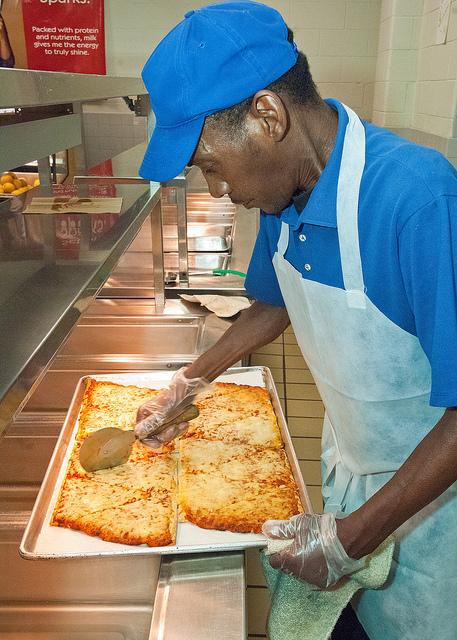What kind of meat is in the pan?
Answer briefly. Pizza. Is the man wearing gloves?
Give a very brief answer. Yes. What is he using to slice the pizza?
Answer briefly. Pizza cutter. What is the man cutting?
Keep it brief. Pizza. Is the man wearing an apron?
Concise answer only. Yes. 